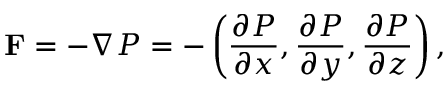Convert formula to latex. <formula><loc_0><loc_0><loc_500><loc_500>F = - \nabla P = - \left ( { \frac { \partial P } { \partial x } } , { \frac { \partial P } { \partial y } } , { \frac { \partial P } { \partial z } } \right ) ,</formula> 